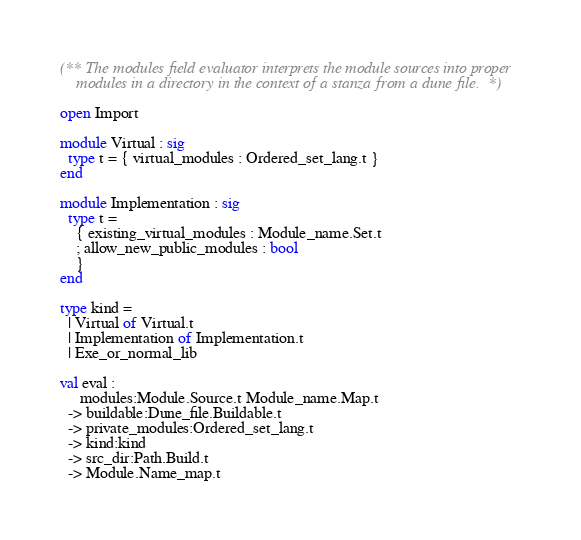Convert code to text. <code><loc_0><loc_0><loc_500><loc_500><_OCaml_>(** The modules field evaluator interprets the module sources into proper
    modules in a directory in the context of a stanza from a dune file. *)

open Import

module Virtual : sig
  type t = { virtual_modules : Ordered_set_lang.t }
end

module Implementation : sig
  type t =
    { existing_virtual_modules : Module_name.Set.t
    ; allow_new_public_modules : bool
    }
end

type kind =
  | Virtual of Virtual.t
  | Implementation of Implementation.t
  | Exe_or_normal_lib

val eval :
     modules:Module.Source.t Module_name.Map.t
  -> buildable:Dune_file.Buildable.t
  -> private_modules:Ordered_set_lang.t
  -> kind:kind
  -> src_dir:Path.Build.t
  -> Module.Name_map.t
</code> 